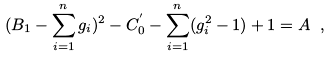Convert formula to latex. <formula><loc_0><loc_0><loc_500><loc_500>( B _ { 1 } - \sum _ { i = 1 } ^ { n } g _ { i } ) ^ { 2 } - C _ { 0 } ^ { ^ { \prime } } - \sum _ { i = 1 } ^ { n } ( g _ { i } ^ { 2 } - 1 ) + 1 = A \ ,</formula> 